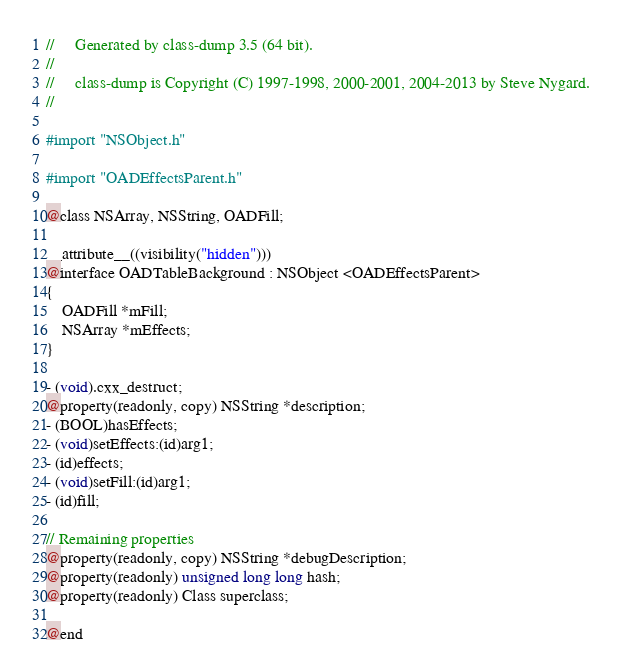<code> <loc_0><loc_0><loc_500><loc_500><_C_>//     Generated by class-dump 3.5 (64 bit).
//
//     class-dump is Copyright (C) 1997-1998, 2000-2001, 2004-2013 by Steve Nygard.
//

#import "NSObject.h"

#import "OADEffectsParent.h"

@class NSArray, NSString, OADFill;

__attribute__((visibility("hidden")))
@interface OADTableBackground : NSObject <OADEffectsParent>
{
    OADFill *mFill;
    NSArray *mEffects;
}

- (void).cxx_destruct;
@property(readonly, copy) NSString *description;
- (BOOL)hasEffects;
- (void)setEffects:(id)arg1;
- (id)effects;
- (void)setFill:(id)arg1;
- (id)fill;

// Remaining properties
@property(readonly, copy) NSString *debugDescription;
@property(readonly) unsigned long long hash;
@property(readonly) Class superclass;

@end

</code> 